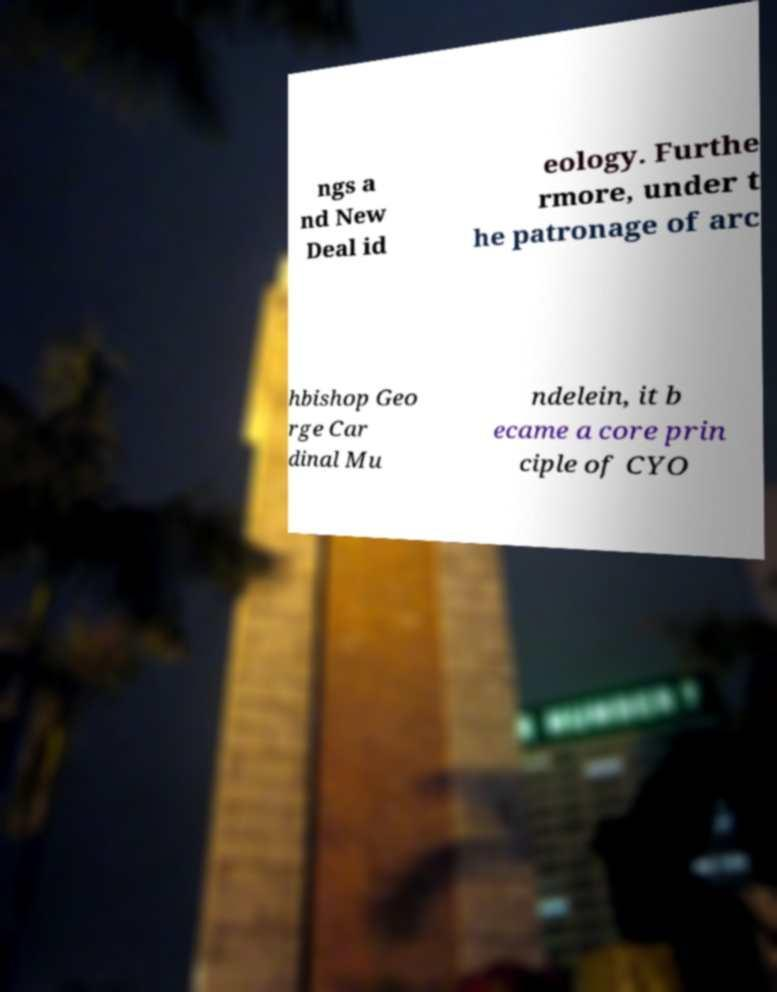Can you accurately transcribe the text from the provided image for me? ngs a nd New Deal id eology. Furthe rmore, under t he patronage of arc hbishop Geo rge Car dinal Mu ndelein, it b ecame a core prin ciple of CYO 